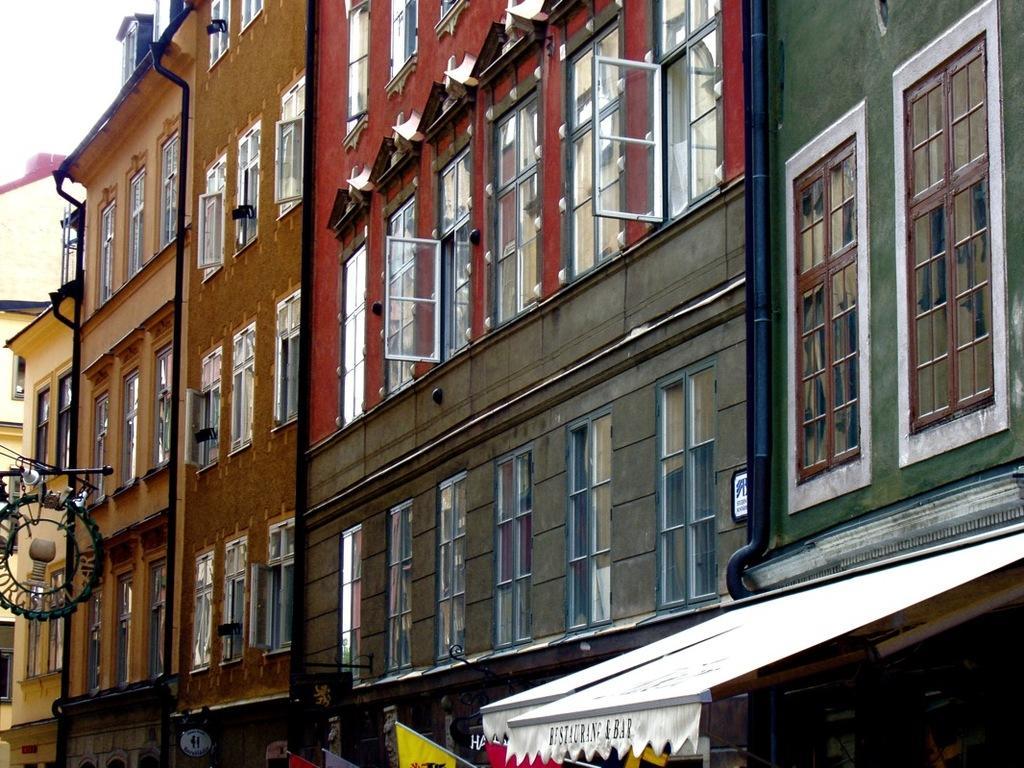Describe this image in one or two sentences. At the bottom there is a shed and there are flags of different colors and in the middle there are very big buildings with glass windows. On the left side there is an iron thing in circular shape. 